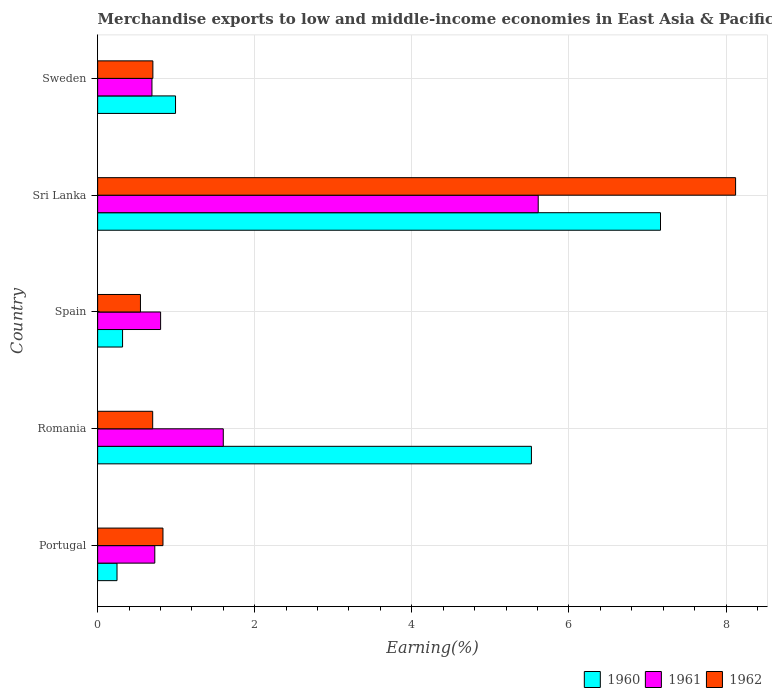How many groups of bars are there?
Keep it short and to the point. 5. How many bars are there on the 4th tick from the top?
Ensure brevity in your answer.  3. What is the label of the 3rd group of bars from the top?
Offer a terse response. Spain. In how many cases, is the number of bars for a given country not equal to the number of legend labels?
Your answer should be very brief. 0. What is the percentage of amount earned from merchandise exports in 1960 in Romania?
Make the answer very short. 5.52. Across all countries, what is the maximum percentage of amount earned from merchandise exports in 1962?
Provide a short and direct response. 8.12. Across all countries, what is the minimum percentage of amount earned from merchandise exports in 1960?
Offer a terse response. 0.25. In which country was the percentage of amount earned from merchandise exports in 1962 maximum?
Offer a very short reply. Sri Lanka. What is the total percentage of amount earned from merchandise exports in 1962 in the graph?
Your answer should be compact. 10.9. What is the difference between the percentage of amount earned from merchandise exports in 1961 in Sri Lanka and that in Sweden?
Provide a succinct answer. 4.92. What is the difference between the percentage of amount earned from merchandise exports in 1961 in Sri Lanka and the percentage of amount earned from merchandise exports in 1960 in Spain?
Provide a succinct answer. 5.29. What is the average percentage of amount earned from merchandise exports in 1962 per country?
Your answer should be compact. 2.18. What is the difference between the percentage of amount earned from merchandise exports in 1960 and percentage of amount earned from merchandise exports in 1961 in Spain?
Your answer should be very brief. -0.48. What is the ratio of the percentage of amount earned from merchandise exports in 1961 in Spain to that in Sweden?
Make the answer very short. 1.16. Is the difference between the percentage of amount earned from merchandise exports in 1960 in Romania and Sweden greater than the difference between the percentage of amount earned from merchandise exports in 1961 in Romania and Sweden?
Ensure brevity in your answer.  Yes. What is the difference between the highest and the second highest percentage of amount earned from merchandise exports in 1962?
Your answer should be compact. 7.29. What is the difference between the highest and the lowest percentage of amount earned from merchandise exports in 1961?
Keep it short and to the point. 4.92. Is the sum of the percentage of amount earned from merchandise exports in 1961 in Romania and Sri Lanka greater than the maximum percentage of amount earned from merchandise exports in 1960 across all countries?
Your answer should be compact. Yes. How many countries are there in the graph?
Your answer should be very brief. 5. What is the difference between two consecutive major ticks on the X-axis?
Make the answer very short. 2. Are the values on the major ticks of X-axis written in scientific E-notation?
Ensure brevity in your answer.  No. Does the graph contain any zero values?
Your answer should be compact. No. Where does the legend appear in the graph?
Offer a terse response. Bottom right. How are the legend labels stacked?
Provide a succinct answer. Horizontal. What is the title of the graph?
Ensure brevity in your answer.  Merchandise exports to low and middle-income economies in East Asia & Pacific. What is the label or title of the X-axis?
Offer a terse response. Earning(%). What is the Earning(%) in 1960 in Portugal?
Ensure brevity in your answer.  0.25. What is the Earning(%) in 1961 in Portugal?
Your response must be concise. 0.73. What is the Earning(%) of 1962 in Portugal?
Offer a terse response. 0.83. What is the Earning(%) in 1960 in Romania?
Offer a terse response. 5.52. What is the Earning(%) in 1961 in Romania?
Ensure brevity in your answer.  1.6. What is the Earning(%) of 1962 in Romania?
Your response must be concise. 0.7. What is the Earning(%) of 1960 in Spain?
Give a very brief answer. 0.32. What is the Earning(%) of 1961 in Spain?
Provide a succinct answer. 0.8. What is the Earning(%) of 1962 in Spain?
Your answer should be very brief. 0.55. What is the Earning(%) in 1960 in Sri Lanka?
Give a very brief answer. 7.17. What is the Earning(%) of 1961 in Sri Lanka?
Your answer should be compact. 5.61. What is the Earning(%) in 1962 in Sri Lanka?
Give a very brief answer. 8.12. What is the Earning(%) of 1960 in Sweden?
Provide a succinct answer. 0.99. What is the Earning(%) in 1961 in Sweden?
Make the answer very short. 0.69. What is the Earning(%) in 1962 in Sweden?
Keep it short and to the point. 0.7. Across all countries, what is the maximum Earning(%) of 1960?
Ensure brevity in your answer.  7.17. Across all countries, what is the maximum Earning(%) in 1961?
Your response must be concise. 5.61. Across all countries, what is the maximum Earning(%) in 1962?
Your response must be concise. 8.12. Across all countries, what is the minimum Earning(%) in 1960?
Ensure brevity in your answer.  0.25. Across all countries, what is the minimum Earning(%) in 1961?
Provide a succinct answer. 0.69. Across all countries, what is the minimum Earning(%) in 1962?
Keep it short and to the point. 0.55. What is the total Earning(%) in 1960 in the graph?
Make the answer very short. 14.24. What is the total Earning(%) of 1961 in the graph?
Give a very brief answer. 9.43. What is the total Earning(%) of 1962 in the graph?
Keep it short and to the point. 10.9. What is the difference between the Earning(%) in 1960 in Portugal and that in Romania?
Your answer should be compact. -5.28. What is the difference between the Earning(%) in 1961 in Portugal and that in Romania?
Offer a very short reply. -0.87. What is the difference between the Earning(%) of 1962 in Portugal and that in Romania?
Keep it short and to the point. 0.13. What is the difference between the Earning(%) of 1960 in Portugal and that in Spain?
Keep it short and to the point. -0.07. What is the difference between the Earning(%) of 1961 in Portugal and that in Spain?
Make the answer very short. -0.07. What is the difference between the Earning(%) in 1962 in Portugal and that in Spain?
Your answer should be very brief. 0.29. What is the difference between the Earning(%) of 1960 in Portugal and that in Sri Lanka?
Provide a short and direct response. -6.92. What is the difference between the Earning(%) in 1961 in Portugal and that in Sri Lanka?
Make the answer very short. -4.88. What is the difference between the Earning(%) in 1962 in Portugal and that in Sri Lanka?
Provide a succinct answer. -7.29. What is the difference between the Earning(%) in 1960 in Portugal and that in Sweden?
Your answer should be compact. -0.74. What is the difference between the Earning(%) in 1961 in Portugal and that in Sweden?
Your answer should be compact. 0.04. What is the difference between the Earning(%) in 1962 in Portugal and that in Sweden?
Provide a short and direct response. 0.13. What is the difference between the Earning(%) in 1960 in Romania and that in Spain?
Your answer should be very brief. 5.21. What is the difference between the Earning(%) of 1961 in Romania and that in Spain?
Offer a very short reply. 0.8. What is the difference between the Earning(%) of 1962 in Romania and that in Spain?
Make the answer very short. 0.16. What is the difference between the Earning(%) of 1960 in Romania and that in Sri Lanka?
Your answer should be very brief. -1.64. What is the difference between the Earning(%) of 1961 in Romania and that in Sri Lanka?
Provide a succinct answer. -4.01. What is the difference between the Earning(%) in 1962 in Romania and that in Sri Lanka?
Provide a short and direct response. -7.42. What is the difference between the Earning(%) in 1960 in Romania and that in Sweden?
Make the answer very short. 4.53. What is the difference between the Earning(%) in 1961 in Romania and that in Sweden?
Your response must be concise. 0.91. What is the difference between the Earning(%) of 1962 in Romania and that in Sweden?
Your answer should be compact. -0. What is the difference between the Earning(%) of 1960 in Spain and that in Sri Lanka?
Offer a very short reply. -6.85. What is the difference between the Earning(%) of 1961 in Spain and that in Sri Lanka?
Your response must be concise. -4.81. What is the difference between the Earning(%) of 1962 in Spain and that in Sri Lanka?
Give a very brief answer. -7.58. What is the difference between the Earning(%) in 1960 in Spain and that in Sweden?
Provide a short and direct response. -0.67. What is the difference between the Earning(%) of 1961 in Spain and that in Sweden?
Offer a very short reply. 0.11. What is the difference between the Earning(%) in 1962 in Spain and that in Sweden?
Your answer should be very brief. -0.16. What is the difference between the Earning(%) in 1960 in Sri Lanka and that in Sweden?
Ensure brevity in your answer.  6.17. What is the difference between the Earning(%) of 1961 in Sri Lanka and that in Sweden?
Ensure brevity in your answer.  4.92. What is the difference between the Earning(%) in 1962 in Sri Lanka and that in Sweden?
Ensure brevity in your answer.  7.42. What is the difference between the Earning(%) in 1960 in Portugal and the Earning(%) in 1961 in Romania?
Your answer should be very brief. -1.35. What is the difference between the Earning(%) in 1960 in Portugal and the Earning(%) in 1962 in Romania?
Offer a terse response. -0.45. What is the difference between the Earning(%) of 1961 in Portugal and the Earning(%) of 1962 in Romania?
Your answer should be compact. 0.03. What is the difference between the Earning(%) of 1960 in Portugal and the Earning(%) of 1961 in Spain?
Your answer should be very brief. -0.56. What is the difference between the Earning(%) of 1960 in Portugal and the Earning(%) of 1962 in Spain?
Your answer should be very brief. -0.3. What is the difference between the Earning(%) in 1961 in Portugal and the Earning(%) in 1962 in Spain?
Offer a terse response. 0.18. What is the difference between the Earning(%) of 1960 in Portugal and the Earning(%) of 1961 in Sri Lanka?
Offer a very short reply. -5.36. What is the difference between the Earning(%) of 1960 in Portugal and the Earning(%) of 1962 in Sri Lanka?
Provide a short and direct response. -7.88. What is the difference between the Earning(%) of 1961 in Portugal and the Earning(%) of 1962 in Sri Lanka?
Offer a very short reply. -7.39. What is the difference between the Earning(%) of 1960 in Portugal and the Earning(%) of 1961 in Sweden?
Give a very brief answer. -0.44. What is the difference between the Earning(%) in 1960 in Portugal and the Earning(%) in 1962 in Sweden?
Your answer should be compact. -0.46. What is the difference between the Earning(%) of 1961 in Portugal and the Earning(%) of 1962 in Sweden?
Provide a succinct answer. 0.02. What is the difference between the Earning(%) of 1960 in Romania and the Earning(%) of 1961 in Spain?
Ensure brevity in your answer.  4.72. What is the difference between the Earning(%) of 1960 in Romania and the Earning(%) of 1962 in Spain?
Your answer should be compact. 4.98. What is the difference between the Earning(%) in 1961 in Romania and the Earning(%) in 1962 in Spain?
Provide a succinct answer. 1.05. What is the difference between the Earning(%) in 1960 in Romania and the Earning(%) in 1961 in Sri Lanka?
Offer a very short reply. -0.09. What is the difference between the Earning(%) of 1960 in Romania and the Earning(%) of 1962 in Sri Lanka?
Your answer should be compact. -2.6. What is the difference between the Earning(%) in 1961 in Romania and the Earning(%) in 1962 in Sri Lanka?
Offer a very short reply. -6.52. What is the difference between the Earning(%) in 1960 in Romania and the Earning(%) in 1961 in Sweden?
Ensure brevity in your answer.  4.83. What is the difference between the Earning(%) in 1960 in Romania and the Earning(%) in 1962 in Sweden?
Your answer should be compact. 4.82. What is the difference between the Earning(%) in 1961 in Romania and the Earning(%) in 1962 in Sweden?
Your answer should be very brief. 0.9. What is the difference between the Earning(%) of 1960 in Spain and the Earning(%) of 1961 in Sri Lanka?
Offer a very short reply. -5.29. What is the difference between the Earning(%) of 1960 in Spain and the Earning(%) of 1962 in Sri Lanka?
Ensure brevity in your answer.  -7.8. What is the difference between the Earning(%) of 1961 in Spain and the Earning(%) of 1962 in Sri Lanka?
Provide a short and direct response. -7.32. What is the difference between the Earning(%) in 1960 in Spain and the Earning(%) in 1961 in Sweden?
Ensure brevity in your answer.  -0.37. What is the difference between the Earning(%) in 1960 in Spain and the Earning(%) in 1962 in Sweden?
Offer a terse response. -0.39. What is the difference between the Earning(%) in 1961 in Spain and the Earning(%) in 1962 in Sweden?
Give a very brief answer. 0.1. What is the difference between the Earning(%) in 1960 in Sri Lanka and the Earning(%) in 1961 in Sweden?
Provide a succinct answer. 6.47. What is the difference between the Earning(%) of 1960 in Sri Lanka and the Earning(%) of 1962 in Sweden?
Offer a terse response. 6.46. What is the difference between the Earning(%) in 1961 in Sri Lanka and the Earning(%) in 1962 in Sweden?
Your answer should be compact. 4.91. What is the average Earning(%) in 1960 per country?
Provide a succinct answer. 2.85. What is the average Earning(%) of 1961 per country?
Your answer should be compact. 1.89. What is the average Earning(%) of 1962 per country?
Provide a succinct answer. 2.18. What is the difference between the Earning(%) of 1960 and Earning(%) of 1961 in Portugal?
Offer a very short reply. -0.48. What is the difference between the Earning(%) in 1960 and Earning(%) in 1962 in Portugal?
Your answer should be compact. -0.58. What is the difference between the Earning(%) in 1961 and Earning(%) in 1962 in Portugal?
Provide a short and direct response. -0.1. What is the difference between the Earning(%) of 1960 and Earning(%) of 1961 in Romania?
Offer a very short reply. 3.92. What is the difference between the Earning(%) in 1960 and Earning(%) in 1962 in Romania?
Your answer should be compact. 4.82. What is the difference between the Earning(%) of 1961 and Earning(%) of 1962 in Romania?
Ensure brevity in your answer.  0.9. What is the difference between the Earning(%) in 1960 and Earning(%) in 1961 in Spain?
Your response must be concise. -0.48. What is the difference between the Earning(%) in 1960 and Earning(%) in 1962 in Spain?
Keep it short and to the point. -0.23. What is the difference between the Earning(%) in 1961 and Earning(%) in 1962 in Spain?
Ensure brevity in your answer.  0.26. What is the difference between the Earning(%) in 1960 and Earning(%) in 1961 in Sri Lanka?
Your answer should be compact. 1.56. What is the difference between the Earning(%) in 1960 and Earning(%) in 1962 in Sri Lanka?
Make the answer very short. -0.96. What is the difference between the Earning(%) in 1961 and Earning(%) in 1962 in Sri Lanka?
Provide a succinct answer. -2.51. What is the difference between the Earning(%) of 1960 and Earning(%) of 1961 in Sweden?
Your answer should be very brief. 0.3. What is the difference between the Earning(%) in 1960 and Earning(%) in 1962 in Sweden?
Your response must be concise. 0.29. What is the difference between the Earning(%) in 1961 and Earning(%) in 1962 in Sweden?
Your answer should be very brief. -0.01. What is the ratio of the Earning(%) of 1960 in Portugal to that in Romania?
Keep it short and to the point. 0.04. What is the ratio of the Earning(%) in 1961 in Portugal to that in Romania?
Your answer should be very brief. 0.45. What is the ratio of the Earning(%) of 1962 in Portugal to that in Romania?
Provide a succinct answer. 1.19. What is the ratio of the Earning(%) in 1960 in Portugal to that in Spain?
Your response must be concise. 0.78. What is the ratio of the Earning(%) of 1961 in Portugal to that in Spain?
Keep it short and to the point. 0.91. What is the ratio of the Earning(%) of 1962 in Portugal to that in Spain?
Ensure brevity in your answer.  1.53. What is the ratio of the Earning(%) in 1960 in Portugal to that in Sri Lanka?
Your response must be concise. 0.03. What is the ratio of the Earning(%) of 1961 in Portugal to that in Sri Lanka?
Make the answer very short. 0.13. What is the ratio of the Earning(%) of 1962 in Portugal to that in Sri Lanka?
Your response must be concise. 0.1. What is the ratio of the Earning(%) of 1960 in Portugal to that in Sweden?
Make the answer very short. 0.25. What is the ratio of the Earning(%) in 1961 in Portugal to that in Sweden?
Provide a succinct answer. 1.05. What is the ratio of the Earning(%) in 1962 in Portugal to that in Sweden?
Keep it short and to the point. 1.18. What is the ratio of the Earning(%) of 1960 in Romania to that in Spain?
Provide a short and direct response. 17.41. What is the ratio of the Earning(%) in 1961 in Romania to that in Spain?
Offer a very short reply. 2. What is the ratio of the Earning(%) in 1962 in Romania to that in Spain?
Offer a very short reply. 1.29. What is the ratio of the Earning(%) of 1960 in Romania to that in Sri Lanka?
Provide a short and direct response. 0.77. What is the ratio of the Earning(%) of 1961 in Romania to that in Sri Lanka?
Ensure brevity in your answer.  0.29. What is the ratio of the Earning(%) in 1962 in Romania to that in Sri Lanka?
Offer a very short reply. 0.09. What is the ratio of the Earning(%) of 1960 in Romania to that in Sweden?
Provide a short and direct response. 5.57. What is the ratio of the Earning(%) of 1961 in Romania to that in Sweden?
Ensure brevity in your answer.  2.31. What is the ratio of the Earning(%) of 1960 in Spain to that in Sri Lanka?
Your response must be concise. 0.04. What is the ratio of the Earning(%) in 1961 in Spain to that in Sri Lanka?
Your response must be concise. 0.14. What is the ratio of the Earning(%) of 1962 in Spain to that in Sri Lanka?
Provide a short and direct response. 0.07. What is the ratio of the Earning(%) in 1960 in Spain to that in Sweden?
Keep it short and to the point. 0.32. What is the ratio of the Earning(%) in 1961 in Spain to that in Sweden?
Make the answer very short. 1.16. What is the ratio of the Earning(%) of 1962 in Spain to that in Sweden?
Your response must be concise. 0.78. What is the ratio of the Earning(%) of 1960 in Sri Lanka to that in Sweden?
Make the answer very short. 7.23. What is the ratio of the Earning(%) in 1961 in Sri Lanka to that in Sweden?
Your answer should be compact. 8.11. What is the ratio of the Earning(%) of 1962 in Sri Lanka to that in Sweden?
Make the answer very short. 11.55. What is the difference between the highest and the second highest Earning(%) in 1960?
Your response must be concise. 1.64. What is the difference between the highest and the second highest Earning(%) in 1961?
Your response must be concise. 4.01. What is the difference between the highest and the second highest Earning(%) of 1962?
Your answer should be compact. 7.29. What is the difference between the highest and the lowest Earning(%) in 1960?
Your answer should be very brief. 6.92. What is the difference between the highest and the lowest Earning(%) of 1961?
Keep it short and to the point. 4.92. What is the difference between the highest and the lowest Earning(%) in 1962?
Your answer should be very brief. 7.58. 